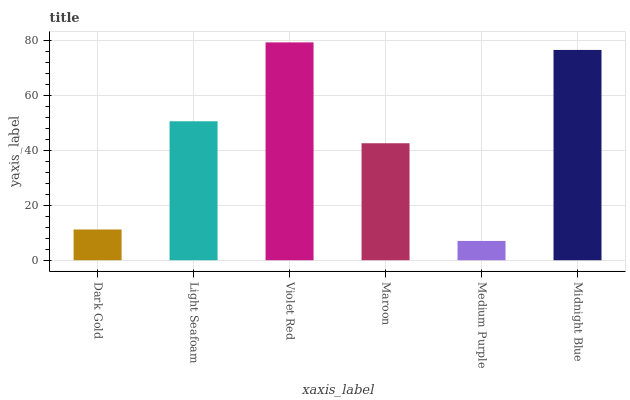Is Medium Purple the minimum?
Answer yes or no. Yes. Is Violet Red the maximum?
Answer yes or no. Yes. Is Light Seafoam the minimum?
Answer yes or no. No. Is Light Seafoam the maximum?
Answer yes or no. No. Is Light Seafoam greater than Dark Gold?
Answer yes or no. Yes. Is Dark Gold less than Light Seafoam?
Answer yes or no. Yes. Is Dark Gold greater than Light Seafoam?
Answer yes or no. No. Is Light Seafoam less than Dark Gold?
Answer yes or no. No. Is Light Seafoam the high median?
Answer yes or no. Yes. Is Maroon the low median?
Answer yes or no. Yes. Is Midnight Blue the high median?
Answer yes or no. No. Is Midnight Blue the low median?
Answer yes or no. No. 